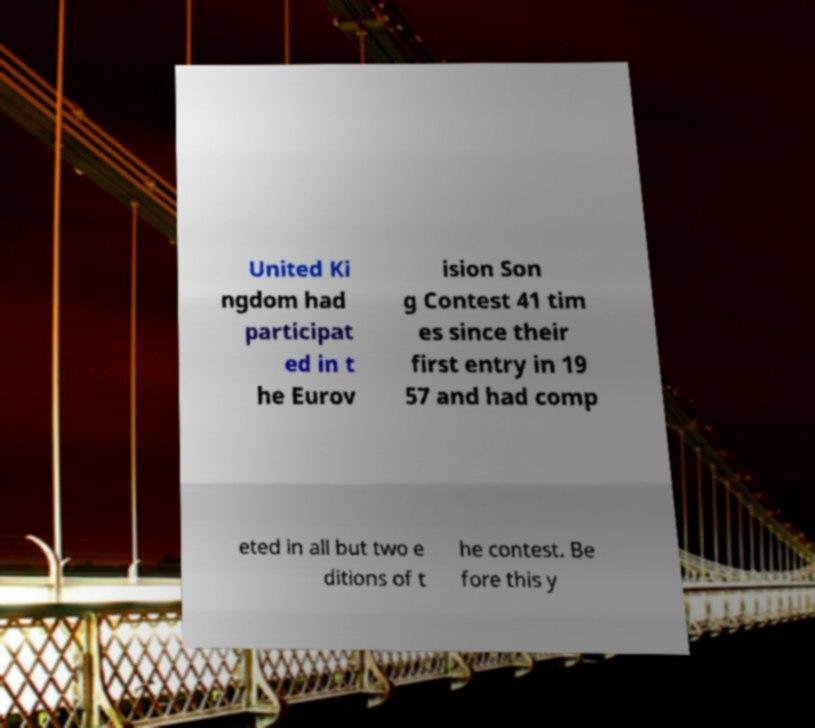I need the written content from this picture converted into text. Can you do that? United Ki ngdom had participat ed in t he Eurov ision Son g Contest 41 tim es since their first entry in 19 57 and had comp eted in all but two e ditions of t he contest. Be fore this y 